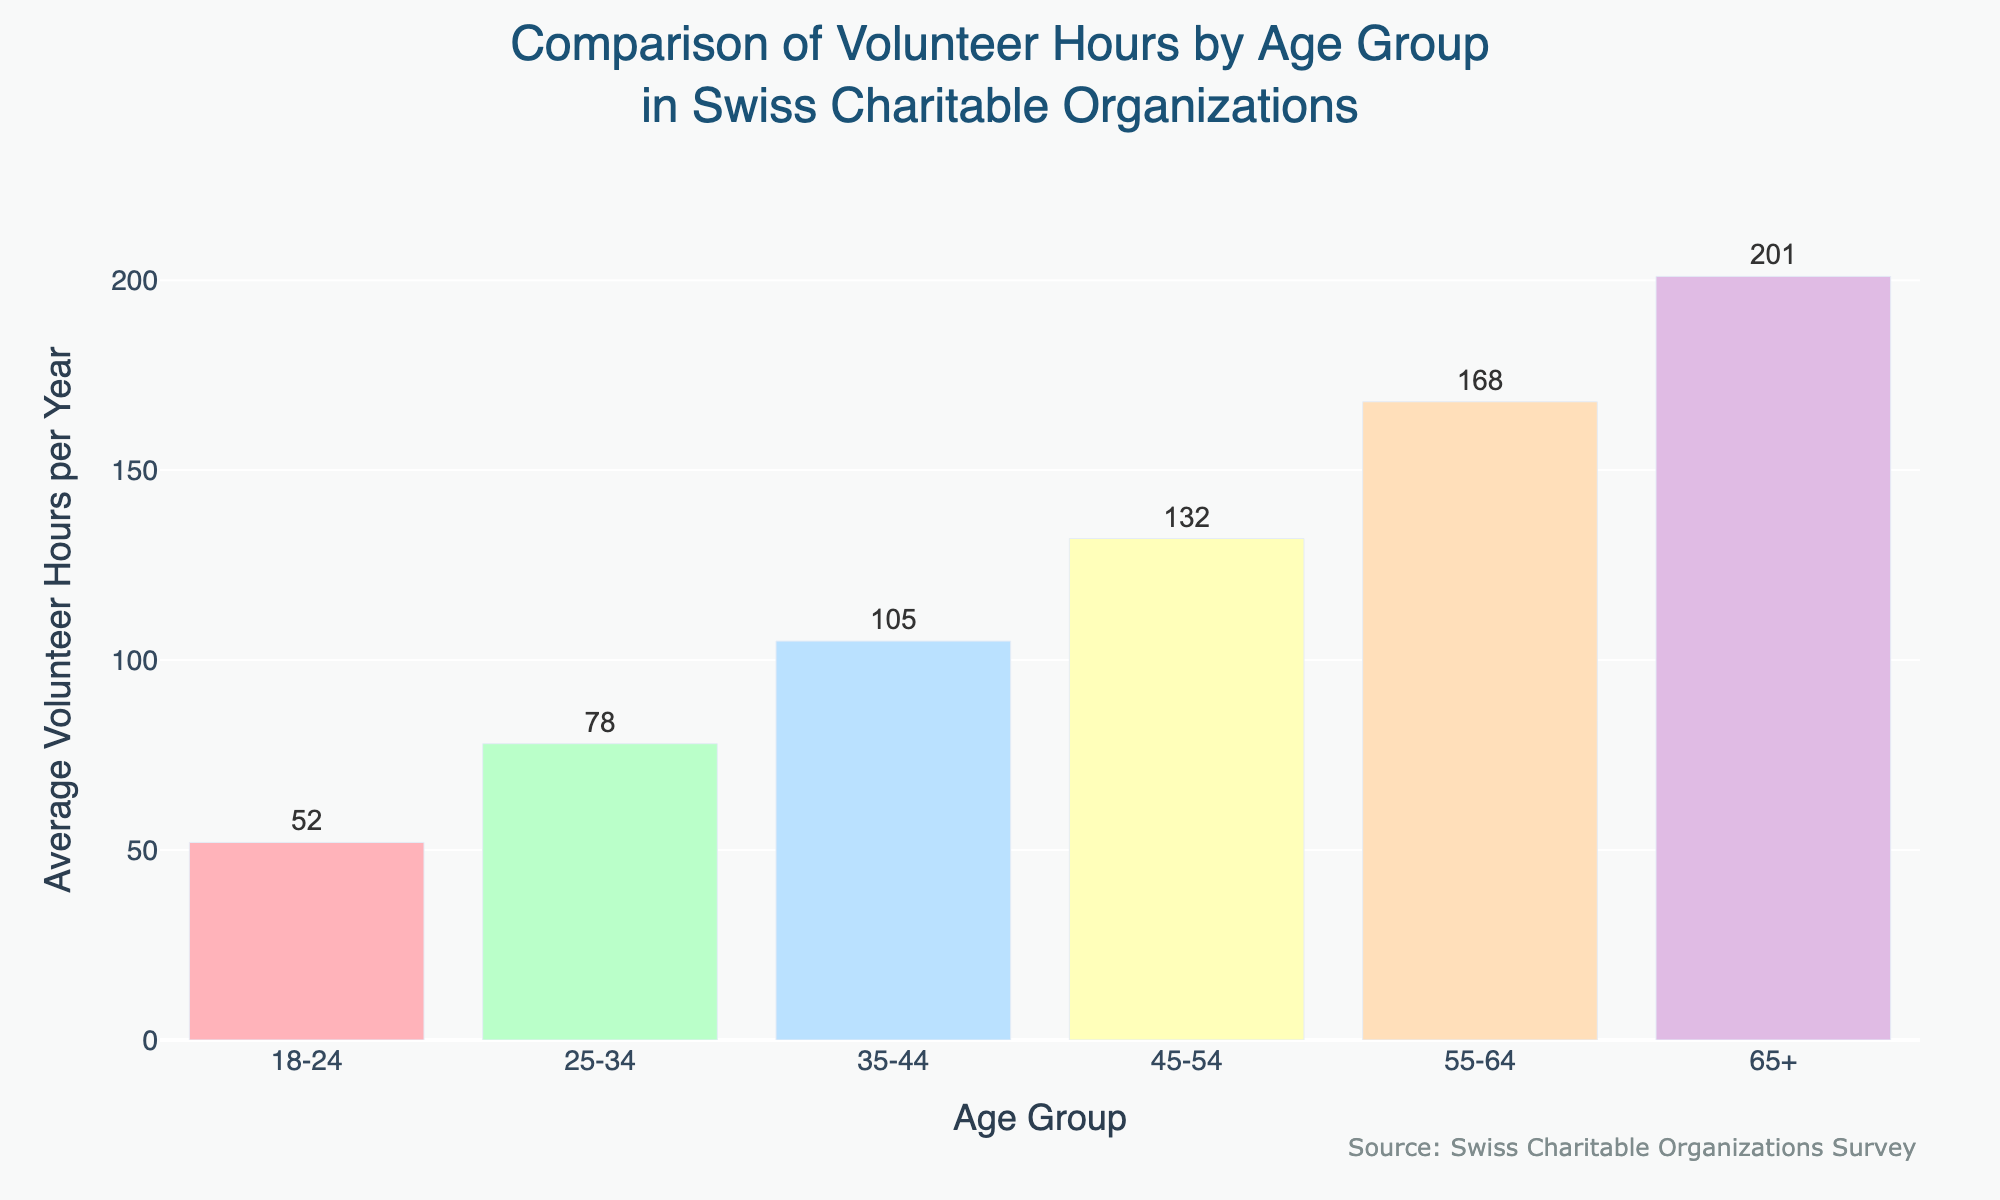What's the total number of average volunteer hours from all age groups combined? To find the total, sum up the average volunteer hours for each age group: 52 + 78 + 105 + 132 + 168 + 201. The total is 736 hours.
Answer: 736 Which age group contributes the most volunteer hours? By comparing the heights of the bars, the 65+ age group has the highest bar, indicating the most hours.
Answer: 65+ How many more volunteer hours do the 55-64 age group contribute compared to the 18-24 age group? Subtract the average hours of the 18-24 group from the 55-64 group: 168 - 52 = 116.
Answer: 116 Which age group has volunteer hours closest to the average of all groups? First, calculate the average of all hours: (52 + 78 + 105 + 132 + 168 + 201) / 6 ≈ 122.67. The age group with hours closest to 122.67 is the 45-54 group with 132 hours.
Answer: 45-54 Identify the age group with the smallest increase in volunteer hours compared to the previous group. Calculate the differences between consecutive age groups: 
(25-34) - (18-24) = 26, 
(35-44) - (25-34) = 27, 
(45-54) - (35-44) = 27, 
(55-64) - (45-54) = 36, 
(65+) - (55-64) = 33. 
The smallest difference is between the 25-34 and 18-24 groups, which is 26 hours.
Answer: 25-34 What is the ratio of volunteer hours between the 35-44 age group and 45-54 age group? Divide the hours of the 45-54 age group by the 35-44 group: 132 / 105 ≈ 1.26.
Answer: 1.26 Which age group has volunteer hours represented by the yellow bar? The yellow bar corresponds to the 45-54 age group based on its position and color in the chart.
Answer: 45-54 What is the percentage increase in volunteer hours from the 25-34 age group to the 65+ age group? First, find the difference: 201 - 78 = 123. Then, divide by the initial value and multiply by 100: (123 / 78) * 100 ≈ 157.69%.
Answer: 157.69% 